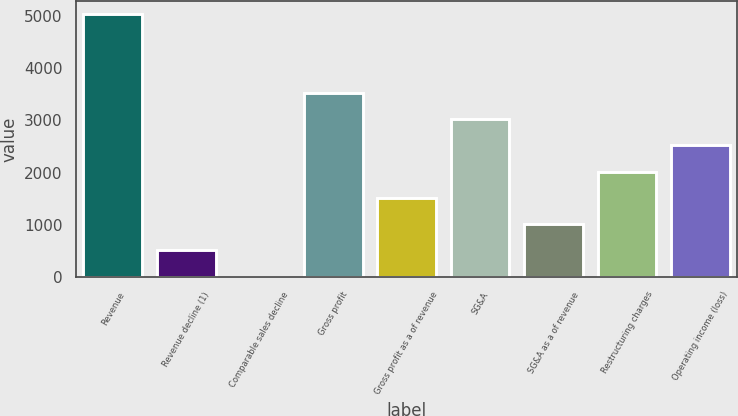<chart> <loc_0><loc_0><loc_500><loc_500><bar_chart><fcel>Revenue<fcel>Revenue decline (1)<fcel>Comparable sales decline<fcel>Gross profit<fcel>Gross profit as a of revenue<fcel>SG&A<fcel>SG&A as a of revenue<fcel>Restructuring charges<fcel>Operating income (loss)<nl><fcel>5030<fcel>511.19<fcel>9.1<fcel>3523.73<fcel>1515.37<fcel>3021.64<fcel>1013.28<fcel>2017.46<fcel>2519.55<nl></chart> 